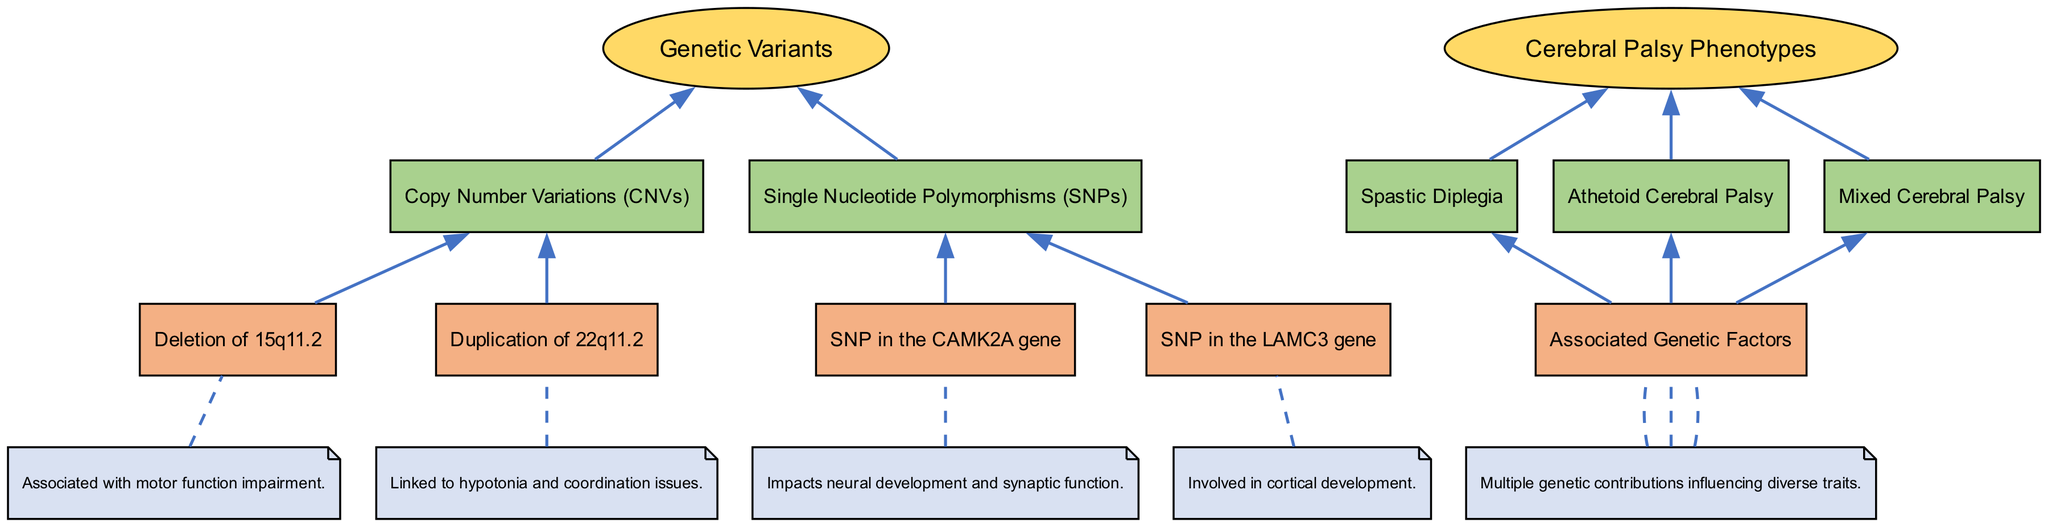What are the two types of genetic variants associated with cerebral palsy? The diagram lists two major types of genetic variants: Copy Number Variations and Single Nucleotide Polymorphisms.
Answer: Copy Number Variations, Single Nucleotide Polymorphisms Which genetic variant is linked to hypotonia? In the diagram, the duplication of 22q11.2 under the Copy Number Variations category is specifically linked to hypotonia and coordination issues.
Answer: Duplication of 22q11.2 What phenotype is associated with dysregulation of dopaminergic pathways? According to the diagram, Athetoid Cerebral Palsy is associated with the dysregulation of dopaminergic pathways highlighting this specific relationship.
Answer: Athetoid Cerebral Palsy How many sub-nodes are there under Cerebral Palsy Phenotypes? The diagram presents three sub-nodes under the Cerebral Palsy Phenotypes node: Spastic Diplegia, Athetoid Cerebral Palsy, and Mixed Cerebral Palsy, totaling three sub-nodes.
Answer: 3 What does the SNP in the CAMK2A gene impact? The diagram indicates that the SNP in the CAMK2A gene impacts neural development and synaptic function, directly connecting this genetic variant to developmental aspects.
Answer: Neural development and synaptic function Which phenotype encompasses multiple genetic contributions? The Mixed Cerebral Palsy phenotype is noted in the diagram as one that involves multiple genetic contributions influencing a variety of traits.
Answer: Mixed Cerebral Palsy What node is positioned at the bottom of the flowchart? The flowchart indicates that the bottom node is Cerebral Palsy Phenotypes, as it follows the genetic variants and specifies their associations with different phenotypes.
Answer: Cerebral Palsy Phenotypes What specific deletion is mentioned under Copy Number Variations? The diagram specifically mentions the deletion of 15q11.2 under Copy Number Variations as a significant genetic alteration impacting motor function.
Answer: Deletion of 15q11.2 